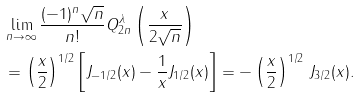<formula> <loc_0><loc_0><loc_500><loc_500>& \lim _ { n \to \infty } \frac { ( - 1 ) ^ { n } \sqrt { n } } { n ! } Q ^ { \lambda } _ { 2 n } \left ( \frac { x } { 2 \sqrt { n } } \right ) \\ & = \left ( \frac { x } { 2 } \right ) ^ { 1 / 2 } \left [ J _ { - 1 / 2 } ( x ) - \frac { 1 } { x } J _ { 1 / 2 } ( x ) \right ] = - \left ( \frac { x } { 2 } \right ) ^ { 1 / 2 } \, J _ { 3 / 2 } ( x ) .</formula> 